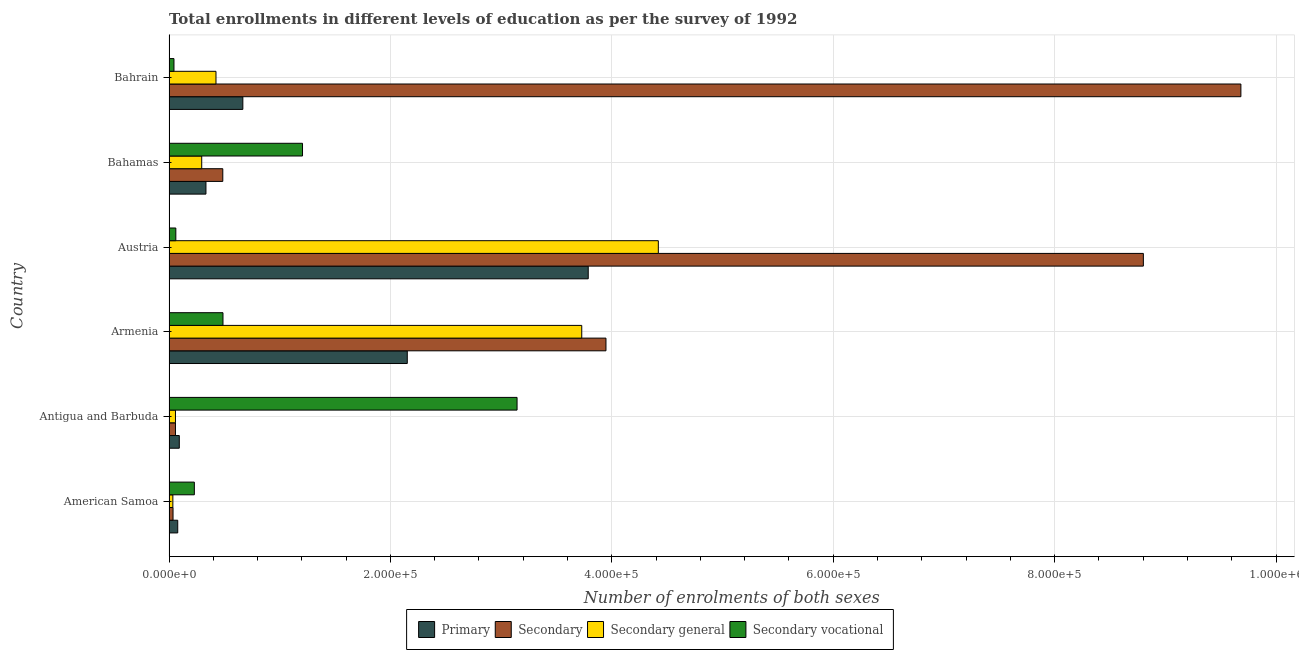How many different coloured bars are there?
Offer a very short reply. 4. How many groups of bars are there?
Keep it short and to the point. 6. Are the number of bars per tick equal to the number of legend labels?
Provide a succinct answer. Yes. How many bars are there on the 6th tick from the top?
Offer a terse response. 4. In how many cases, is the number of bars for a given country not equal to the number of legend labels?
Make the answer very short. 0. What is the number of enrolments in primary education in Austria?
Your response must be concise. 3.79e+05. Across all countries, what is the maximum number of enrolments in primary education?
Give a very brief answer. 3.79e+05. Across all countries, what is the minimum number of enrolments in secondary vocational education?
Ensure brevity in your answer.  4485. In which country was the number of enrolments in secondary vocational education maximum?
Your answer should be very brief. Antigua and Barbuda. In which country was the number of enrolments in secondary vocational education minimum?
Ensure brevity in your answer.  Bahrain. What is the total number of enrolments in secondary education in the graph?
Your response must be concise. 2.30e+06. What is the difference between the number of enrolments in secondary general education in Antigua and Barbuda and that in Austria?
Your response must be concise. -4.36e+05. What is the difference between the number of enrolments in secondary vocational education in Armenia and the number of enrolments in secondary education in Bahrain?
Offer a very short reply. -9.19e+05. What is the average number of enrolments in secondary vocational education per country?
Ensure brevity in your answer.  8.62e+04. What is the difference between the number of enrolments in primary education and number of enrolments in secondary general education in Armenia?
Your answer should be very brief. -1.58e+05. What is the ratio of the number of enrolments in secondary vocational education in Antigua and Barbuda to that in Bahamas?
Offer a terse response. 2.61. What is the difference between the highest and the second highest number of enrolments in secondary vocational education?
Give a very brief answer. 1.94e+05. What is the difference between the highest and the lowest number of enrolments in secondary general education?
Ensure brevity in your answer.  4.39e+05. Is the sum of the number of enrolments in secondary general education in Antigua and Barbuda and Austria greater than the maximum number of enrolments in secondary education across all countries?
Give a very brief answer. No. What does the 2nd bar from the top in Bahamas represents?
Your answer should be very brief. Secondary general. What does the 3rd bar from the bottom in Antigua and Barbuda represents?
Keep it short and to the point. Secondary general. Is it the case that in every country, the sum of the number of enrolments in primary education and number of enrolments in secondary education is greater than the number of enrolments in secondary general education?
Offer a very short reply. Yes. How many bars are there?
Offer a terse response. 24. Are all the bars in the graph horizontal?
Offer a very short reply. Yes. How many countries are there in the graph?
Give a very brief answer. 6. What is the difference between two consecutive major ticks on the X-axis?
Provide a succinct answer. 2.00e+05. What is the title of the graph?
Give a very brief answer. Total enrollments in different levels of education as per the survey of 1992. What is the label or title of the X-axis?
Your answer should be compact. Number of enrolments of both sexes. What is the Number of enrolments of both sexes in Primary in American Samoa?
Offer a very short reply. 7884. What is the Number of enrolments of both sexes in Secondary in American Samoa?
Provide a short and direct response. 3643. What is the Number of enrolments of both sexes in Secondary general in American Samoa?
Provide a succinct answer. 3483. What is the Number of enrolments of both sexes in Secondary vocational in American Samoa?
Provide a short and direct response. 2.29e+04. What is the Number of enrolments of both sexes of Primary in Antigua and Barbuda?
Provide a succinct answer. 9298. What is the Number of enrolments of both sexes of Secondary in Antigua and Barbuda?
Keep it short and to the point. 5845. What is the Number of enrolments of both sexes in Secondary general in Antigua and Barbuda?
Your answer should be compact. 5845. What is the Number of enrolments of both sexes of Secondary vocational in Antigua and Barbuda?
Offer a very short reply. 3.14e+05. What is the Number of enrolments of both sexes of Primary in Armenia?
Your answer should be compact. 2.15e+05. What is the Number of enrolments of both sexes of Secondary in Armenia?
Your answer should be very brief. 3.95e+05. What is the Number of enrolments of both sexes in Secondary general in Armenia?
Provide a short and direct response. 3.73e+05. What is the Number of enrolments of both sexes of Secondary vocational in Armenia?
Your answer should be compact. 4.88e+04. What is the Number of enrolments of both sexes of Primary in Austria?
Your answer should be compact. 3.79e+05. What is the Number of enrolments of both sexes in Secondary in Austria?
Your answer should be compact. 8.80e+05. What is the Number of enrolments of both sexes of Secondary general in Austria?
Keep it short and to the point. 4.42e+05. What is the Number of enrolments of both sexes of Secondary vocational in Austria?
Offer a terse response. 6165. What is the Number of enrolments of both sexes of Primary in Bahamas?
Provide a short and direct response. 3.34e+04. What is the Number of enrolments of both sexes in Secondary in Bahamas?
Keep it short and to the point. 4.86e+04. What is the Number of enrolments of both sexes in Secondary general in Bahamas?
Ensure brevity in your answer.  2.96e+04. What is the Number of enrolments of both sexes in Secondary vocational in Bahamas?
Your response must be concise. 1.21e+05. What is the Number of enrolments of both sexes of Primary in Bahrain?
Make the answer very short. 6.67e+04. What is the Number of enrolments of both sexes of Secondary in Bahrain?
Keep it short and to the point. 9.68e+05. What is the Number of enrolments of both sexes in Secondary general in Bahrain?
Ensure brevity in your answer.  4.24e+04. What is the Number of enrolments of both sexes of Secondary vocational in Bahrain?
Your response must be concise. 4485. Across all countries, what is the maximum Number of enrolments of both sexes of Primary?
Keep it short and to the point. 3.79e+05. Across all countries, what is the maximum Number of enrolments of both sexes of Secondary?
Offer a very short reply. 9.68e+05. Across all countries, what is the maximum Number of enrolments of both sexes in Secondary general?
Provide a succinct answer. 4.42e+05. Across all countries, what is the maximum Number of enrolments of both sexes of Secondary vocational?
Your answer should be very brief. 3.14e+05. Across all countries, what is the minimum Number of enrolments of both sexes of Primary?
Give a very brief answer. 7884. Across all countries, what is the minimum Number of enrolments of both sexes of Secondary?
Your answer should be very brief. 3643. Across all countries, what is the minimum Number of enrolments of both sexes of Secondary general?
Make the answer very short. 3483. Across all countries, what is the minimum Number of enrolments of both sexes in Secondary vocational?
Offer a terse response. 4485. What is the total Number of enrolments of both sexes in Primary in the graph?
Give a very brief answer. 7.11e+05. What is the total Number of enrolments of both sexes of Secondary in the graph?
Your answer should be compact. 2.30e+06. What is the total Number of enrolments of both sexes of Secondary general in the graph?
Provide a short and direct response. 8.96e+05. What is the total Number of enrolments of both sexes of Secondary vocational in the graph?
Your answer should be compact. 5.17e+05. What is the difference between the Number of enrolments of both sexes of Primary in American Samoa and that in Antigua and Barbuda?
Your answer should be very brief. -1414. What is the difference between the Number of enrolments of both sexes in Secondary in American Samoa and that in Antigua and Barbuda?
Offer a terse response. -2202. What is the difference between the Number of enrolments of both sexes in Secondary general in American Samoa and that in Antigua and Barbuda?
Provide a succinct answer. -2362. What is the difference between the Number of enrolments of both sexes in Secondary vocational in American Samoa and that in Antigua and Barbuda?
Offer a very short reply. -2.92e+05. What is the difference between the Number of enrolments of both sexes in Primary in American Samoa and that in Armenia?
Provide a succinct answer. -2.07e+05. What is the difference between the Number of enrolments of both sexes of Secondary in American Samoa and that in Armenia?
Ensure brevity in your answer.  -3.91e+05. What is the difference between the Number of enrolments of both sexes of Secondary general in American Samoa and that in Armenia?
Give a very brief answer. -3.69e+05. What is the difference between the Number of enrolments of both sexes of Secondary vocational in American Samoa and that in Armenia?
Provide a succinct answer. -2.59e+04. What is the difference between the Number of enrolments of both sexes in Primary in American Samoa and that in Austria?
Your answer should be very brief. -3.71e+05. What is the difference between the Number of enrolments of both sexes in Secondary in American Samoa and that in Austria?
Your answer should be compact. -8.76e+05. What is the difference between the Number of enrolments of both sexes in Secondary general in American Samoa and that in Austria?
Offer a very short reply. -4.39e+05. What is the difference between the Number of enrolments of both sexes of Secondary vocational in American Samoa and that in Austria?
Your answer should be compact. 1.67e+04. What is the difference between the Number of enrolments of both sexes in Primary in American Samoa and that in Bahamas?
Your answer should be very brief. -2.55e+04. What is the difference between the Number of enrolments of both sexes of Secondary in American Samoa and that in Bahamas?
Ensure brevity in your answer.  -4.50e+04. What is the difference between the Number of enrolments of both sexes in Secondary general in American Samoa and that in Bahamas?
Your answer should be compact. -2.61e+04. What is the difference between the Number of enrolments of both sexes in Secondary vocational in American Samoa and that in Bahamas?
Your answer should be very brief. -9.77e+04. What is the difference between the Number of enrolments of both sexes in Primary in American Samoa and that in Bahrain?
Ensure brevity in your answer.  -5.88e+04. What is the difference between the Number of enrolments of both sexes of Secondary in American Samoa and that in Bahrain?
Your response must be concise. -9.65e+05. What is the difference between the Number of enrolments of both sexes of Secondary general in American Samoa and that in Bahrain?
Offer a terse response. -3.90e+04. What is the difference between the Number of enrolments of both sexes of Secondary vocational in American Samoa and that in Bahrain?
Offer a terse response. 1.84e+04. What is the difference between the Number of enrolments of both sexes of Primary in Antigua and Barbuda and that in Armenia?
Your response must be concise. -2.06e+05. What is the difference between the Number of enrolments of both sexes in Secondary in Antigua and Barbuda and that in Armenia?
Offer a terse response. -3.89e+05. What is the difference between the Number of enrolments of both sexes of Secondary general in Antigua and Barbuda and that in Armenia?
Make the answer very short. -3.67e+05. What is the difference between the Number of enrolments of both sexes of Secondary vocational in Antigua and Barbuda and that in Armenia?
Your answer should be very brief. 2.66e+05. What is the difference between the Number of enrolments of both sexes in Primary in Antigua and Barbuda and that in Austria?
Ensure brevity in your answer.  -3.69e+05. What is the difference between the Number of enrolments of both sexes in Secondary in Antigua and Barbuda and that in Austria?
Provide a succinct answer. -8.74e+05. What is the difference between the Number of enrolments of both sexes of Secondary general in Antigua and Barbuda and that in Austria?
Your answer should be very brief. -4.36e+05. What is the difference between the Number of enrolments of both sexes in Secondary vocational in Antigua and Barbuda and that in Austria?
Provide a short and direct response. 3.08e+05. What is the difference between the Number of enrolments of both sexes of Primary in Antigua and Barbuda and that in Bahamas?
Provide a succinct answer. -2.41e+04. What is the difference between the Number of enrolments of both sexes in Secondary in Antigua and Barbuda and that in Bahamas?
Offer a very short reply. -4.28e+04. What is the difference between the Number of enrolments of both sexes of Secondary general in Antigua and Barbuda and that in Bahamas?
Keep it short and to the point. -2.37e+04. What is the difference between the Number of enrolments of both sexes of Secondary vocational in Antigua and Barbuda and that in Bahamas?
Your answer should be very brief. 1.94e+05. What is the difference between the Number of enrolments of both sexes of Primary in Antigua and Barbuda and that in Bahrain?
Provide a succinct answer. -5.74e+04. What is the difference between the Number of enrolments of both sexes in Secondary in Antigua and Barbuda and that in Bahrain?
Your answer should be compact. -9.62e+05. What is the difference between the Number of enrolments of both sexes in Secondary general in Antigua and Barbuda and that in Bahrain?
Make the answer very short. -3.66e+04. What is the difference between the Number of enrolments of both sexes in Secondary vocational in Antigua and Barbuda and that in Bahrain?
Your answer should be very brief. 3.10e+05. What is the difference between the Number of enrolments of both sexes in Primary in Armenia and that in Austria?
Offer a terse response. -1.63e+05. What is the difference between the Number of enrolments of both sexes of Secondary in Armenia and that in Austria?
Ensure brevity in your answer.  -4.85e+05. What is the difference between the Number of enrolments of both sexes of Secondary general in Armenia and that in Austria?
Ensure brevity in your answer.  -6.92e+04. What is the difference between the Number of enrolments of both sexes of Secondary vocational in Armenia and that in Austria?
Provide a succinct answer. 4.26e+04. What is the difference between the Number of enrolments of both sexes in Primary in Armenia and that in Bahamas?
Offer a terse response. 1.82e+05. What is the difference between the Number of enrolments of both sexes in Secondary in Armenia and that in Bahamas?
Make the answer very short. 3.46e+05. What is the difference between the Number of enrolments of both sexes in Secondary general in Armenia and that in Bahamas?
Provide a short and direct response. 3.43e+05. What is the difference between the Number of enrolments of both sexes in Secondary vocational in Armenia and that in Bahamas?
Your answer should be compact. -7.18e+04. What is the difference between the Number of enrolments of both sexes of Primary in Armenia and that in Bahrain?
Keep it short and to the point. 1.49e+05. What is the difference between the Number of enrolments of both sexes of Secondary in Armenia and that in Bahrain?
Your response must be concise. -5.73e+05. What is the difference between the Number of enrolments of both sexes in Secondary general in Armenia and that in Bahrain?
Give a very brief answer. 3.30e+05. What is the difference between the Number of enrolments of both sexes in Secondary vocational in Armenia and that in Bahrain?
Your response must be concise. 4.43e+04. What is the difference between the Number of enrolments of both sexes in Primary in Austria and that in Bahamas?
Give a very brief answer. 3.45e+05. What is the difference between the Number of enrolments of both sexes of Secondary in Austria and that in Bahamas?
Offer a very short reply. 8.31e+05. What is the difference between the Number of enrolments of both sexes in Secondary general in Austria and that in Bahamas?
Your answer should be very brief. 4.12e+05. What is the difference between the Number of enrolments of both sexes of Secondary vocational in Austria and that in Bahamas?
Ensure brevity in your answer.  -1.14e+05. What is the difference between the Number of enrolments of both sexes of Primary in Austria and that in Bahrain?
Offer a very short reply. 3.12e+05. What is the difference between the Number of enrolments of both sexes in Secondary in Austria and that in Bahrain?
Offer a very short reply. -8.81e+04. What is the difference between the Number of enrolments of both sexes in Secondary general in Austria and that in Bahrain?
Keep it short and to the point. 4.00e+05. What is the difference between the Number of enrolments of both sexes in Secondary vocational in Austria and that in Bahrain?
Ensure brevity in your answer.  1680. What is the difference between the Number of enrolments of both sexes of Primary in Bahamas and that in Bahrain?
Offer a very short reply. -3.33e+04. What is the difference between the Number of enrolments of both sexes of Secondary in Bahamas and that in Bahrain?
Keep it short and to the point. -9.20e+05. What is the difference between the Number of enrolments of both sexes in Secondary general in Bahamas and that in Bahrain?
Provide a short and direct response. -1.29e+04. What is the difference between the Number of enrolments of both sexes in Secondary vocational in Bahamas and that in Bahrain?
Offer a terse response. 1.16e+05. What is the difference between the Number of enrolments of both sexes of Primary in American Samoa and the Number of enrolments of both sexes of Secondary in Antigua and Barbuda?
Your answer should be compact. 2039. What is the difference between the Number of enrolments of both sexes of Primary in American Samoa and the Number of enrolments of both sexes of Secondary general in Antigua and Barbuda?
Ensure brevity in your answer.  2039. What is the difference between the Number of enrolments of both sexes in Primary in American Samoa and the Number of enrolments of both sexes in Secondary vocational in Antigua and Barbuda?
Provide a succinct answer. -3.07e+05. What is the difference between the Number of enrolments of both sexes in Secondary in American Samoa and the Number of enrolments of both sexes in Secondary general in Antigua and Barbuda?
Offer a very short reply. -2202. What is the difference between the Number of enrolments of both sexes in Secondary in American Samoa and the Number of enrolments of both sexes in Secondary vocational in Antigua and Barbuda?
Your answer should be very brief. -3.11e+05. What is the difference between the Number of enrolments of both sexes of Secondary general in American Samoa and the Number of enrolments of both sexes of Secondary vocational in Antigua and Barbuda?
Provide a succinct answer. -3.11e+05. What is the difference between the Number of enrolments of both sexes in Primary in American Samoa and the Number of enrolments of both sexes in Secondary in Armenia?
Provide a succinct answer. -3.87e+05. What is the difference between the Number of enrolments of both sexes in Primary in American Samoa and the Number of enrolments of both sexes in Secondary general in Armenia?
Offer a terse response. -3.65e+05. What is the difference between the Number of enrolments of both sexes of Primary in American Samoa and the Number of enrolments of both sexes of Secondary vocational in Armenia?
Your answer should be compact. -4.09e+04. What is the difference between the Number of enrolments of both sexes of Secondary in American Samoa and the Number of enrolments of both sexes of Secondary general in Armenia?
Make the answer very short. -3.69e+05. What is the difference between the Number of enrolments of both sexes in Secondary in American Samoa and the Number of enrolments of both sexes in Secondary vocational in Armenia?
Your answer should be compact. -4.51e+04. What is the difference between the Number of enrolments of both sexes of Secondary general in American Samoa and the Number of enrolments of both sexes of Secondary vocational in Armenia?
Your answer should be compact. -4.53e+04. What is the difference between the Number of enrolments of both sexes of Primary in American Samoa and the Number of enrolments of both sexes of Secondary in Austria?
Keep it short and to the point. -8.72e+05. What is the difference between the Number of enrolments of both sexes of Primary in American Samoa and the Number of enrolments of both sexes of Secondary general in Austria?
Offer a very short reply. -4.34e+05. What is the difference between the Number of enrolments of both sexes of Primary in American Samoa and the Number of enrolments of both sexes of Secondary vocational in Austria?
Provide a succinct answer. 1719. What is the difference between the Number of enrolments of both sexes in Secondary in American Samoa and the Number of enrolments of both sexes in Secondary general in Austria?
Offer a very short reply. -4.38e+05. What is the difference between the Number of enrolments of both sexes of Secondary in American Samoa and the Number of enrolments of both sexes of Secondary vocational in Austria?
Make the answer very short. -2522. What is the difference between the Number of enrolments of both sexes in Secondary general in American Samoa and the Number of enrolments of both sexes in Secondary vocational in Austria?
Provide a succinct answer. -2682. What is the difference between the Number of enrolments of both sexes in Primary in American Samoa and the Number of enrolments of both sexes in Secondary in Bahamas?
Offer a very short reply. -4.07e+04. What is the difference between the Number of enrolments of both sexes of Primary in American Samoa and the Number of enrolments of both sexes of Secondary general in Bahamas?
Give a very brief answer. -2.17e+04. What is the difference between the Number of enrolments of both sexes of Primary in American Samoa and the Number of enrolments of both sexes of Secondary vocational in Bahamas?
Make the answer very short. -1.13e+05. What is the difference between the Number of enrolments of both sexes in Secondary in American Samoa and the Number of enrolments of both sexes in Secondary general in Bahamas?
Offer a very short reply. -2.59e+04. What is the difference between the Number of enrolments of both sexes of Secondary in American Samoa and the Number of enrolments of both sexes of Secondary vocational in Bahamas?
Offer a terse response. -1.17e+05. What is the difference between the Number of enrolments of both sexes of Secondary general in American Samoa and the Number of enrolments of both sexes of Secondary vocational in Bahamas?
Offer a terse response. -1.17e+05. What is the difference between the Number of enrolments of both sexes in Primary in American Samoa and the Number of enrolments of both sexes in Secondary in Bahrain?
Give a very brief answer. -9.60e+05. What is the difference between the Number of enrolments of both sexes of Primary in American Samoa and the Number of enrolments of both sexes of Secondary general in Bahrain?
Your answer should be compact. -3.46e+04. What is the difference between the Number of enrolments of both sexes of Primary in American Samoa and the Number of enrolments of both sexes of Secondary vocational in Bahrain?
Your response must be concise. 3399. What is the difference between the Number of enrolments of both sexes of Secondary in American Samoa and the Number of enrolments of both sexes of Secondary general in Bahrain?
Offer a terse response. -3.88e+04. What is the difference between the Number of enrolments of both sexes in Secondary in American Samoa and the Number of enrolments of both sexes in Secondary vocational in Bahrain?
Ensure brevity in your answer.  -842. What is the difference between the Number of enrolments of both sexes of Secondary general in American Samoa and the Number of enrolments of both sexes of Secondary vocational in Bahrain?
Your answer should be very brief. -1002. What is the difference between the Number of enrolments of both sexes in Primary in Antigua and Barbuda and the Number of enrolments of both sexes in Secondary in Armenia?
Ensure brevity in your answer.  -3.85e+05. What is the difference between the Number of enrolments of both sexes of Primary in Antigua and Barbuda and the Number of enrolments of both sexes of Secondary general in Armenia?
Your response must be concise. -3.64e+05. What is the difference between the Number of enrolments of both sexes of Primary in Antigua and Barbuda and the Number of enrolments of both sexes of Secondary vocational in Armenia?
Give a very brief answer. -3.95e+04. What is the difference between the Number of enrolments of both sexes of Secondary in Antigua and Barbuda and the Number of enrolments of both sexes of Secondary general in Armenia?
Your answer should be very brief. -3.67e+05. What is the difference between the Number of enrolments of both sexes in Secondary in Antigua and Barbuda and the Number of enrolments of both sexes in Secondary vocational in Armenia?
Provide a succinct answer. -4.29e+04. What is the difference between the Number of enrolments of both sexes in Secondary general in Antigua and Barbuda and the Number of enrolments of both sexes in Secondary vocational in Armenia?
Provide a succinct answer. -4.29e+04. What is the difference between the Number of enrolments of both sexes of Primary in Antigua and Barbuda and the Number of enrolments of both sexes of Secondary in Austria?
Provide a short and direct response. -8.71e+05. What is the difference between the Number of enrolments of both sexes of Primary in Antigua and Barbuda and the Number of enrolments of both sexes of Secondary general in Austria?
Your response must be concise. -4.33e+05. What is the difference between the Number of enrolments of both sexes of Primary in Antigua and Barbuda and the Number of enrolments of both sexes of Secondary vocational in Austria?
Provide a succinct answer. 3133. What is the difference between the Number of enrolments of both sexes in Secondary in Antigua and Barbuda and the Number of enrolments of both sexes in Secondary general in Austria?
Give a very brief answer. -4.36e+05. What is the difference between the Number of enrolments of both sexes of Secondary in Antigua and Barbuda and the Number of enrolments of both sexes of Secondary vocational in Austria?
Offer a terse response. -320. What is the difference between the Number of enrolments of both sexes in Secondary general in Antigua and Barbuda and the Number of enrolments of both sexes in Secondary vocational in Austria?
Give a very brief answer. -320. What is the difference between the Number of enrolments of both sexes of Primary in Antigua and Barbuda and the Number of enrolments of both sexes of Secondary in Bahamas?
Make the answer very short. -3.93e+04. What is the difference between the Number of enrolments of both sexes in Primary in Antigua and Barbuda and the Number of enrolments of both sexes in Secondary general in Bahamas?
Keep it short and to the point. -2.03e+04. What is the difference between the Number of enrolments of both sexes of Primary in Antigua and Barbuda and the Number of enrolments of both sexes of Secondary vocational in Bahamas?
Give a very brief answer. -1.11e+05. What is the difference between the Number of enrolments of both sexes in Secondary in Antigua and Barbuda and the Number of enrolments of both sexes in Secondary general in Bahamas?
Ensure brevity in your answer.  -2.37e+04. What is the difference between the Number of enrolments of both sexes of Secondary in Antigua and Barbuda and the Number of enrolments of both sexes of Secondary vocational in Bahamas?
Your response must be concise. -1.15e+05. What is the difference between the Number of enrolments of both sexes in Secondary general in Antigua and Barbuda and the Number of enrolments of both sexes in Secondary vocational in Bahamas?
Give a very brief answer. -1.15e+05. What is the difference between the Number of enrolments of both sexes in Primary in Antigua and Barbuda and the Number of enrolments of both sexes in Secondary in Bahrain?
Your answer should be very brief. -9.59e+05. What is the difference between the Number of enrolments of both sexes in Primary in Antigua and Barbuda and the Number of enrolments of both sexes in Secondary general in Bahrain?
Ensure brevity in your answer.  -3.31e+04. What is the difference between the Number of enrolments of both sexes in Primary in Antigua and Barbuda and the Number of enrolments of both sexes in Secondary vocational in Bahrain?
Keep it short and to the point. 4813. What is the difference between the Number of enrolments of both sexes in Secondary in Antigua and Barbuda and the Number of enrolments of both sexes in Secondary general in Bahrain?
Offer a very short reply. -3.66e+04. What is the difference between the Number of enrolments of both sexes in Secondary in Antigua and Barbuda and the Number of enrolments of both sexes in Secondary vocational in Bahrain?
Your response must be concise. 1360. What is the difference between the Number of enrolments of both sexes in Secondary general in Antigua and Barbuda and the Number of enrolments of both sexes in Secondary vocational in Bahrain?
Offer a terse response. 1360. What is the difference between the Number of enrolments of both sexes in Primary in Armenia and the Number of enrolments of both sexes in Secondary in Austria?
Offer a terse response. -6.65e+05. What is the difference between the Number of enrolments of both sexes of Primary in Armenia and the Number of enrolments of both sexes of Secondary general in Austria?
Offer a very short reply. -2.27e+05. What is the difference between the Number of enrolments of both sexes of Primary in Armenia and the Number of enrolments of both sexes of Secondary vocational in Austria?
Offer a very short reply. 2.09e+05. What is the difference between the Number of enrolments of both sexes in Secondary in Armenia and the Number of enrolments of both sexes in Secondary general in Austria?
Provide a short and direct response. -4.73e+04. What is the difference between the Number of enrolments of both sexes of Secondary in Armenia and the Number of enrolments of both sexes of Secondary vocational in Austria?
Keep it short and to the point. 3.89e+05. What is the difference between the Number of enrolments of both sexes of Secondary general in Armenia and the Number of enrolments of both sexes of Secondary vocational in Austria?
Provide a succinct answer. 3.67e+05. What is the difference between the Number of enrolments of both sexes in Primary in Armenia and the Number of enrolments of both sexes in Secondary in Bahamas?
Provide a short and direct response. 1.67e+05. What is the difference between the Number of enrolments of both sexes in Primary in Armenia and the Number of enrolments of both sexes in Secondary general in Bahamas?
Your answer should be very brief. 1.86e+05. What is the difference between the Number of enrolments of both sexes of Primary in Armenia and the Number of enrolments of both sexes of Secondary vocational in Bahamas?
Ensure brevity in your answer.  9.46e+04. What is the difference between the Number of enrolments of both sexes in Secondary in Armenia and the Number of enrolments of both sexes in Secondary general in Bahamas?
Your answer should be compact. 3.65e+05. What is the difference between the Number of enrolments of both sexes of Secondary in Armenia and the Number of enrolments of both sexes of Secondary vocational in Bahamas?
Ensure brevity in your answer.  2.74e+05. What is the difference between the Number of enrolments of both sexes in Secondary general in Armenia and the Number of enrolments of both sexes in Secondary vocational in Bahamas?
Provide a succinct answer. 2.52e+05. What is the difference between the Number of enrolments of both sexes in Primary in Armenia and the Number of enrolments of both sexes in Secondary in Bahrain?
Your answer should be compact. -7.53e+05. What is the difference between the Number of enrolments of both sexes of Primary in Armenia and the Number of enrolments of both sexes of Secondary general in Bahrain?
Ensure brevity in your answer.  1.73e+05. What is the difference between the Number of enrolments of both sexes in Primary in Armenia and the Number of enrolments of both sexes in Secondary vocational in Bahrain?
Ensure brevity in your answer.  2.11e+05. What is the difference between the Number of enrolments of both sexes in Secondary in Armenia and the Number of enrolments of both sexes in Secondary general in Bahrain?
Offer a terse response. 3.52e+05. What is the difference between the Number of enrolments of both sexes of Secondary in Armenia and the Number of enrolments of both sexes of Secondary vocational in Bahrain?
Offer a very short reply. 3.90e+05. What is the difference between the Number of enrolments of both sexes of Secondary general in Armenia and the Number of enrolments of both sexes of Secondary vocational in Bahrain?
Your answer should be very brief. 3.68e+05. What is the difference between the Number of enrolments of both sexes of Primary in Austria and the Number of enrolments of both sexes of Secondary in Bahamas?
Keep it short and to the point. 3.30e+05. What is the difference between the Number of enrolments of both sexes of Primary in Austria and the Number of enrolments of both sexes of Secondary general in Bahamas?
Your response must be concise. 3.49e+05. What is the difference between the Number of enrolments of both sexes in Primary in Austria and the Number of enrolments of both sexes in Secondary vocational in Bahamas?
Make the answer very short. 2.58e+05. What is the difference between the Number of enrolments of both sexes in Secondary in Austria and the Number of enrolments of both sexes in Secondary general in Bahamas?
Ensure brevity in your answer.  8.51e+05. What is the difference between the Number of enrolments of both sexes of Secondary in Austria and the Number of enrolments of both sexes of Secondary vocational in Bahamas?
Provide a short and direct response. 7.59e+05. What is the difference between the Number of enrolments of both sexes in Secondary general in Austria and the Number of enrolments of both sexes in Secondary vocational in Bahamas?
Ensure brevity in your answer.  3.21e+05. What is the difference between the Number of enrolments of both sexes in Primary in Austria and the Number of enrolments of both sexes in Secondary in Bahrain?
Provide a short and direct response. -5.90e+05. What is the difference between the Number of enrolments of both sexes of Primary in Austria and the Number of enrolments of both sexes of Secondary general in Bahrain?
Keep it short and to the point. 3.36e+05. What is the difference between the Number of enrolments of both sexes of Primary in Austria and the Number of enrolments of both sexes of Secondary vocational in Bahrain?
Offer a terse response. 3.74e+05. What is the difference between the Number of enrolments of both sexes of Secondary in Austria and the Number of enrolments of both sexes of Secondary general in Bahrain?
Offer a terse response. 8.38e+05. What is the difference between the Number of enrolments of both sexes of Secondary in Austria and the Number of enrolments of both sexes of Secondary vocational in Bahrain?
Ensure brevity in your answer.  8.76e+05. What is the difference between the Number of enrolments of both sexes in Secondary general in Austria and the Number of enrolments of both sexes in Secondary vocational in Bahrain?
Make the answer very short. 4.38e+05. What is the difference between the Number of enrolments of both sexes of Primary in Bahamas and the Number of enrolments of both sexes of Secondary in Bahrain?
Keep it short and to the point. -9.35e+05. What is the difference between the Number of enrolments of both sexes of Primary in Bahamas and the Number of enrolments of both sexes of Secondary general in Bahrain?
Keep it short and to the point. -9061. What is the difference between the Number of enrolments of both sexes in Primary in Bahamas and the Number of enrolments of both sexes in Secondary vocational in Bahrain?
Keep it short and to the point. 2.89e+04. What is the difference between the Number of enrolments of both sexes in Secondary in Bahamas and the Number of enrolments of both sexes in Secondary general in Bahrain?
Make the answer very short. 6165. What is the difference between the Number of enrolments of both sexes in Secondary in Bahamas and the Number of enrolments of both sexes in Secondary vocational in Bahrain?
Give a very brief answer. 4.41e+04. What is the difference between the Number of enrolments of both sexes of Secondary general in Bahamas and the Number of enrolments of both sexes of Secondary vocational in Bahrain?
Give a very brief answer. 2.51e+04. What is the average Number of enrolments of both sexes of Primary per country?
Your answer should be compact. 1.19e+05. What is the average Number of enrolments of both sexes of Secondary per country?
Give a very brief answer. 3.84e+05. What is the average Number of enrolments of both sexes in Secondary general per country?
Your answer should be very brief. 1.49e+05. What is the average Number of enrolments of both sexes in Secondary vocational per country?
Offer a terse response. 8.62e+04. What is the difference between the Number of enrolments of both sexes of Primary and Number of enrolments of both sexes of Secondary in American Samoa?
Offer a very short reply. 4241. What is the difference between the Number of enrolments of both sexes in Primary and Number of enrolments of both sexes in Secondary general in American Samoa?
Ensure brevity in your answer.  4401. What is the difference between the Number of enrolments of both sexes of Primary and Number of enrolments of both sexes of Secondary vocational in American Samoa?
Offer a very short reply. -1.50e+04. What is the difference between the Number of enrolments of both sexes in Secondary and Number of enrolments of both sexes in Secondary general in American Samoa?
Make the answer very short. 160. What is the difference between the Number of enrolments of both sexes of Secondary and Number of enrolments of both sexes of Secondary vocational in American Samoa?
Provide a succinct answer. -1.92e+04. What is the difference between the Number of enrolments of both sexes in Secondary general and Number of enrolments of both sexes in Secondary vocational in American Samoa?
Your answer should be very brief. -1.94e+04. What is the difference between the Number of enrolments of both sexes in Primary and Number of enrolments of both sexes in Secondary in Antigua and Barbuda?
Provide a succinct answer. 3453. What is the difference between the Number of enrolments of both sexes in Primary and Number of enrolments of both sexes in Secondary general in Antigua and Barbuda?
Your answer should be compact. 3453. What is the difference between the Number of enrolments of both sexes in Primary and Number of enrolments of both sexes in Secondary vocational in Antigua and Barbuda?
Offer a very short reply. -3.05e+05. What is the difference between the Number of enrolments of both sexes of Secondary and Number of enrolments of both sexes of Secondary vocational in Antigua and Barbuda?
Provide a succinct answer. -3.09e+05. What is the difference between the Number of enrolments of both sexes in Secondary general and Number of enrolments of both sexes in Secondary vocational in Antigua and Barbuda?
Provide a succinct answer. -3.09e+05. What is the difference between the Number of enrolments of both sexes of Primary and Number of enrolments of both sexes of Secondary in Armenia?
Make the answer very short. -1.79e+05. What is the difference between the Number of enrolments of both sexes of Primary and Number of enrolments of both sexes of Secondary general in Armenia?
Give a very brief answer. -1.58e+05. What is the difference between the Number of enrolments of both sexes of Primary and Number of enrolments of both sexes of Secondary vocational in Armenia?
Offer a very short reply. 1.66e+05. What is the difference between the Number of enrolments of both sexes in Secondary and Number of enrolments of both sexes in Secondary general in Armenia?
Ensure brevity in your answer.  2.19e+04. What is the difference between the Number of enrolments of both sexes in Secondary and Number of enrolments of both sexes in Secondary vocational in Armenia?
Your answer should be compact. 3.46e+05. What is the difference between the Number of enrolments of both sexes of Secondary general and Number of enrolments of both sexes of Secondary vocational in Armenia?
Your answer should be very brief. 3.24e+05. What is the difference between the Number of enrolments of both sexes in Primary and Number of enrolments of both sexes in Secondary in Austria?
Your answer should be compact. -5.01e+05. What is the difference between the Number of enrolments of both sexes in Primary and Number of enrolments of both sexes in Secondary general in Austria?
Your answer should be compact. -6.33e+04. What is the difference between the Number of enrolments of both sexes of Primary and Number of enrolments of both sexes of Secondary vocational in Austria?
Your answer should be compact. 3.73e+05. What is the difference between the Number of enrolments of both sexes in Secondary and Number of enrolments of both sexes in Secondary general in Austria?
Offer a terse response. 4.38e+05. What is the difference between the Number of enrolments of both sexes in Secondary and Number of enrolments of both sexes in Secondary vocational in Austria?
Offer a terse response. 8.74e+05. What is the difference between the Number of enrolments of both sexes of Secondary general and Number of enrolments of both sexes of Secondary vocational in Austria?
Give a very brief answer. 4.36e+05. What is the difference between the Number of enrolments of both sexes of Primary and Number of enrolments of both sexes of Secondary in Bahamas?
Offer a very short reply. -1.52e+04. What is the difference between the Number of enrolments of both sexes in Primary and Number of enrolments of both sexes in Secondary general in Bahamas?
Your response must be concise. 3815. What is the difference between the Number of enrolments of both sexes of Primary and Number of enrolments of both sexes of Secondary vocational in Bahamas?
Make the answer very short. -8.72e+04. What is the difference between the Number of enrolments of both sexes of Secondary and Number of enrolments of both sexes of Secondary general in Bahamas?
Offer a very short reply. 1.90e+04. What is the difference between the Number of enrolments of both sexes in Secondary and Number of enrolments of both sexes in Secondary vocational in Bahamas?
Your answer should be very brief. -7.20e+04. What is the difference between the Number of enrolments of both sexes of Secondary general and Number of enrolments of both sexes of Secondary vocational in Bahamas?
Ensure brevity in your answer.  -9.10e+04. What is the difference between the Number of enrolments of both sexes of Primary and Number of enrolments of both sexes of Secondary in Bahrain?
Keep it short and to the point. -9.02e+05. What is the difference between the Number of enrolments of both sexes in Primary and Number of enrolments of both sexes in Secondary general in Bahrain?
Provide a short and direct response. 2.43e+04. What is the difference between the Number of enrolments of both sexes in Primary and Number of enrolments of both sexes in Secondary vocational in Bahrain?
Your answer should be very brief. 6.22e+04. What is the difference between the Number of enrolments of both sexes in Secondary and Number of enrolments of both sexes in Secondary general in Bahrain?
Offer a very short reply. 9.26e+05. What is the difference between the Number of enrolments of both sexes of Secondary and Number of enrolments of both sexes of Secondary vocational in Bahrain?
Provide a short and direct response. 9.64e+05. What is the difference between the Number of enrolments of both sexes in Secondary general and Number of enrolments of both sexes in Secondary vocational in Bahrain?
Offer a terse response. 3.80e+04. What is the ratio of the Number of enrolments of both sexes of Primary in American Samoa to that in Antigua and Barbuda?
Offer a terse response. 0.85. What is the ratio of the Number of enrolments of both sexes of Secondary in American Samoa to that in Antigua and Barbuda?
Give a very brief answer. 0.62. What is the ratio of the Number of enrolments of both sexes of Secondary general in American Samoa to that in Antigua and Barbuda?
Offer a very short reply. 0.6. What is the ratio of the Number of enrolments of both sexes of Secondary vocational in American Samoa to that in Antigua and Barbuda?
Keep it short and to the point. 0.07. What is the ratio of the Number of enrolments of both sexes in Primary in American Samoa to that in Armenia?
Keep it short and to the point. 0.04. What is the ratio of the Number of enrolments of both sexes of Secondary in American Samoa to that in Armenia?
Give a very brief answer. 0.01. What is the ratio of the Number of enrolments of both sexes in Secondary general in American Samoa to that in Armenia?
Ensure brevity in your answer.  0.01. What is the ratio of the Number of enrolments of both sexes in Secondary vocational in American Samoa to that in Armenia?
Your answer should be compact. 0.47. What is the ratio of the Number of enrolments of both sexes of Primary in American Samoa to that in Austria?
Offer a terse response. 0.02. What is the ratio of the Number of enrolments of both sexes of Secondary in American Samoa to that in Austria?
Give a very brief answer. 0. What is the ratio of the Number of enrolments of both sexes of Secondary general in American Samoa to that in Austria?
Your answer should be very brief. 0.01. What is the ratio of the Number of enrolments of both sexes of Secondary vocational in American Samoa to that in Austria?
Ensure brevity in your answer.  3.71. What is the ratio of the Number of enrolments of both sexes of Primary in American Samoa to that in Bahamas?
Provide a succinct answer. 0.24. What is the ratio of the Number of enrolments of both sexes in Secondary in American Samoa to that in Bahamas?
Offer a very short reply. 0.07. What is the ratio of the Number of enrolments of both sexes of Secondary general in American Samoa to that in Bahamas?
Provide a short and direct response. 0.12. What is the ratio of the Number of enrolments of both sexes of Secondary vocational in American Samoa to that in Bahamas?
Keep it short and to the point. 0.19. What is the ratio of the Number of enrolments of both sexes of Primary in American Samoa to that in Bahrain?
Offer a very short reply. 0.12. What is the ratio of the Number of enrolments of both sexes in Secondary in American Samoa to that in Bahrain?
Your answer should be very brief. 0. What is the ratio of the Number of enrolments of both sexes in Secondary general in American Samoa to that in Bahrain?
Offer a very short reply. 0.08. What is the ratio of the Number of enrolments of both sexes in Secondary vocational in American Samoa to that in Bahrain?
Your response must be concise. 5.1. What is the ratio of the Number of enrolments of both sexes of Primary in Antigua and Barbuda to that in Armenia?
Provide a short and direct response. 0.04. What is the ratio of the Number of enrolments of both sexes in Secondary in Antigua and Barbuda to that in Armenia?
Your response must be concise. 0.01. What is the ratio of the Number of enrolments of both sexes of Secondary general in Antigua and Barbuda to that in Armenia?
Your response must be concise. 0.02. What is the ratio of the Number of enrolments of both sexes in Secondary vocational in Antigua and Barbuda to that in Armenia?
Provide a succinct answer. 6.45. What is the ratio of the Number of enrolments of both sexes in Primary in Antigua and Barbuda to that in Austria?
Offer a very short reply. 0.02. What is the ratio of the Number of enrolments of both sexes in Secondary in Antigua and Barbuda to that in Austria?
Make the answer very short. 0.01. What is the ratio of the Number of enrolments of both sexes of Secondary general in Antigua and Barbuda to that in Austria?
Provide a short and direct response. 0.01. What is the ratio of the Number of enrolments of both sexes in Secondary vocational in Antigua and Barbuda to that in Austria?
Ensure brevity in your answer.  51. What is the ratio of the Number of enrolments of both sexes of Primary in Antigua and Barbuda to that in Bahamas?
Provide a succinct answer. 0.28. What is the ratio of the Number of enrolments of both sexes in Secondary in Antigua and Barbuda to that in Bahamas?
Provide a short and direct response. 0.12. What is the ratio of the Number of enrolments of both sexes of Secondary general in Antigua and Barbuda to that in Bahamas?
Your response must be concise. 0.2. What is the ratio of the Number of enrolments of both sexes in Secondary vocational in Antigua and Barbuda to that in Bahamas?
Give a very brief answer. 2.61. What is the ratio of the Number of enrolments of both sexes of Primary in Antigua and Barbuda to that in Bahrain?
Ensure brevity in your answer.  0.14. What is the ratio of the Number of enrolments of both sexes of Secondary in Antigua and Barbuda to that in Bahrain?
Your answer should be compact. 0.01. What is the ratio of the Number of enrolments of both sexes of Secondary general in Antigua and Barbuda to that in Bahrain?
Offer a very short reply. 0.14. What is the ratio of the Number of enrolments of both sexes of Secondary vocational in Antigua and Barbuda to that in Bahrain?
Your answer should be very brief. 70.1. What is the ratio of the Number of enrolments of both sexes of Primary in Armenia to that in Austria?
Your answer should be compact. 0.57. What is the ratio of the Number of enrolments of both sexes in Secondary in Armenia to that in Austria?
Keep it short and to the point. 0.45. What is the ratio of the Number of enrolments of both sexes of Secondary general in Armenia to that in Austria?
Your response must be concise. 0.84. What is the ratio of the Number of enrolments of both sexes in Secondary vocational in Armenia to that in Austria?
Give a very brief answer. 7.91. What is the ratio of the Number of enrolments of both sexes of Primary in Armenia to that in Bahamas?
Your response must be concise. 6.45. What is the ratio of the Number of enrolments of both sexes in Secondary in Armenia to that in Bahamas?
Your answer should be very brief. 8.12. What is the ratio of the Number of enrolments of both sexes in Secondary general in Armenia to that in Bahamas?
Your answer should be compact. 12.61. What is the ratio of the Number of enrolments of both sexes of Secondary vocational in Armenia to that in Bahamas?
Give a very brief answer. 0.4. What is the ratio of the Number of enrolments of both sexes in Primary in Armenia to that in Bahrain?
Keep it short and to the point. 3.23. What is the ratio of the Number of enrolments of both sexes in Secondary in Armenia to that in Bahrain?
Ensure brevity in your answer.  0.41. What is the ratio of the Number of enrolments of both sexes of Secondary general in Armenia to that in Bahrain?
Your answer should be very brief. 8.79. What is the ratio of the Number of enrolments of both sexes of Secondary vocational in Armenia to that in Bahrain?
Keep it short and to the point. 10.87. What is the ratio of the Number of enrolments of both sexes of Primary in Austria to that in Bahamas?
Offer a very short reply. 11.35. What is the ratio of the Number of enrolments of both sexes in Secondary in Austria to that in Bahamas?
Provide a succinct answer. 18.11. What is the ratio of the Number of enrolments of both sexes of Secondary general in Austria to that in Bahamas?
Ensure brevity in your answer.  14.95. What is the ratio of the Number of enrolments of both sexes of Secondary vocational in Austria to that in Bahamas?
Ensure brevity in your answer.  0.05. What is the ratio of the Number of enrolments of both sexes of Primary in Austria to that in Bahrain?
Make the answer very short. 5.68. What is the ratio of the Number of enrolments of both sexes of Secondary in Austria to that in Bahrain?
Ensure brevity in your answer.  0.91. What is the ratio of the Number of enrolments of both sexes of Secondary general in Austria to that in Bahrain?
Provide a succinct answer. 10.42. What is the ratio of the Number of enrolments of both sexes in Secondary vocational in Austria to that in Bahrain?
Give a very brief answer. 1.37. What is the ratio of the Number of enrolments of both sexes of Primary in Bahamas to that in Bahrain?
Provide a succinct answer. 0.5. What is the ratio of the Number of enrolments of both sexes of Secondary in Bahamas to that in Bahrain?
Offer a terse response. 0.05. What is the ratio of the Number of enrolments of both sexes in Secondary general in Bahamas to that in Bahrain?
Provide a short and direct response. 0.7. What is the ratio of the Number of enrolments of both sexes of Secondary vocational in Bahamas to that in Bahrain?
Give a very brief answer. 26.89. What is the difference between the highest and the second highest Number of enrolments of both sexes in Primary?
Give a very brief answer. 1.63e+05. What is the difference between the highest and the second highest Number of enrolments of both sexes of Secondary?
Your response must be concise. 8.81e+04. What is the difference between the highest and the second highest Number of enrolments of both sexes in Secondary general?
Offer a terse response. 6.92e+04. What is the difference between the highest and the second highest Number of enrolments of both sexes of Secondary vocational?
Make the answer very short. 1.94e+05. What is the difference between the highest and the lowest Number of enrolments of both sexes in Primary?
Your response must be concise. 3.71e+05. What is the difference between the highest and the lowest Number of enrolments of both sexes of Secondary?
Give a very brief answer. 9.65e+05. What is the difference between the highest and the lowest Number of enrolments of both sexes of Secondary general?
Provide a succinct answer. 4.39e+05. What is the difference between the highest and the lowest Number of enrolments of both sexes in Secondary vocational?
Offer a terse response. 3.10e+05. 